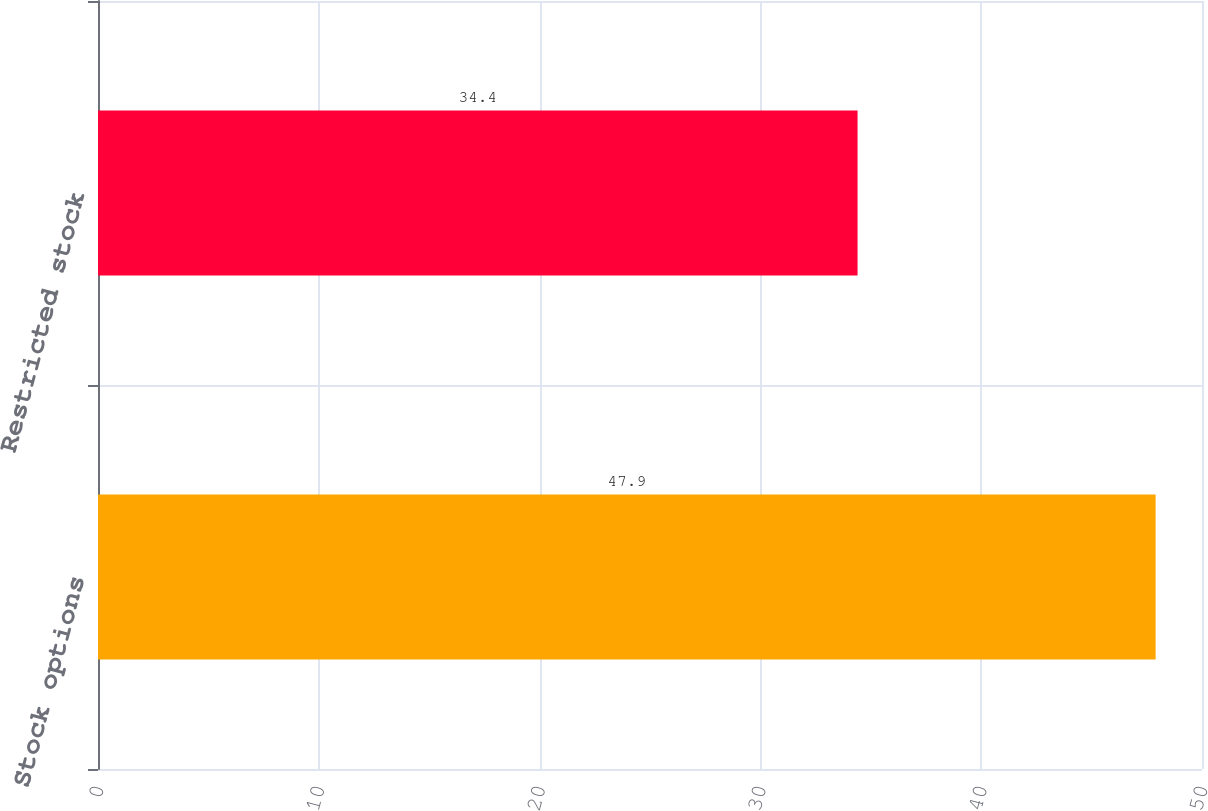Convert chart. <chart><loc_0><loc_0><loc_500><loc_500><bar_chart><fcel>Stock options<fcel>Restricted stock<nl><fcel>47.9<fcel>34.4<nl></chart> 